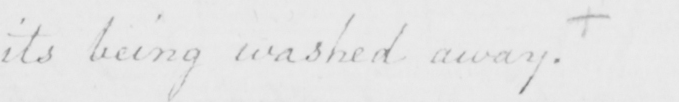What text is written in this handwritten line? its being washed away .  + 